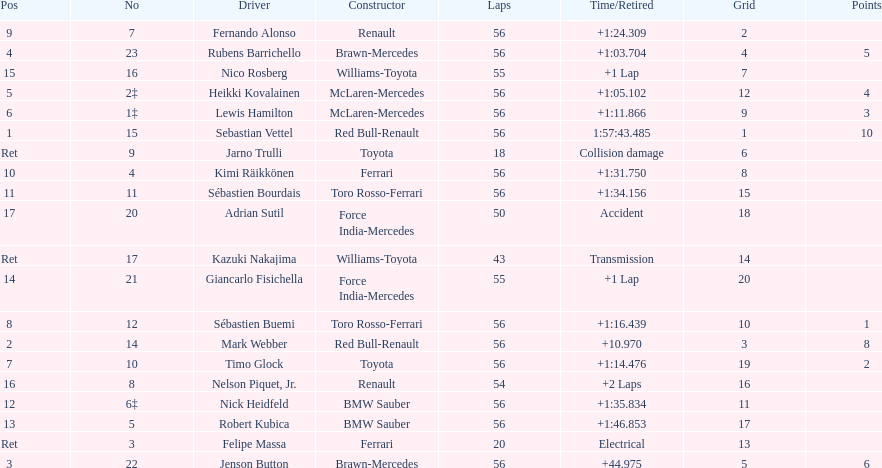What driver was last on the list? Jarno Trulli. 